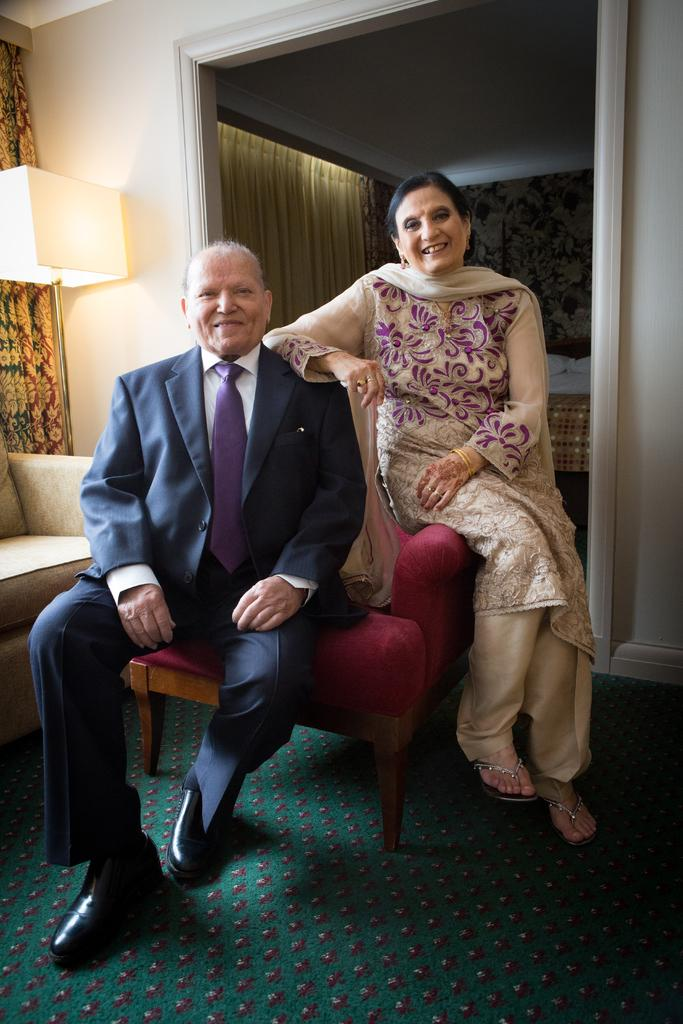Who are the people in the image? There is a man and a woman in the image. What is the man doing in the image? The man is sitting on a couch. What is the man wearing in the image? The man is wearing a suit. What is the woman wearing in the image? The woman is wearing a dress. What type of lighting is present in the image? There is a lantern lamp in the image. How many brothers are present in the image? There is no mention of brothers in the image, so we cannot determine the number of brothers present. 